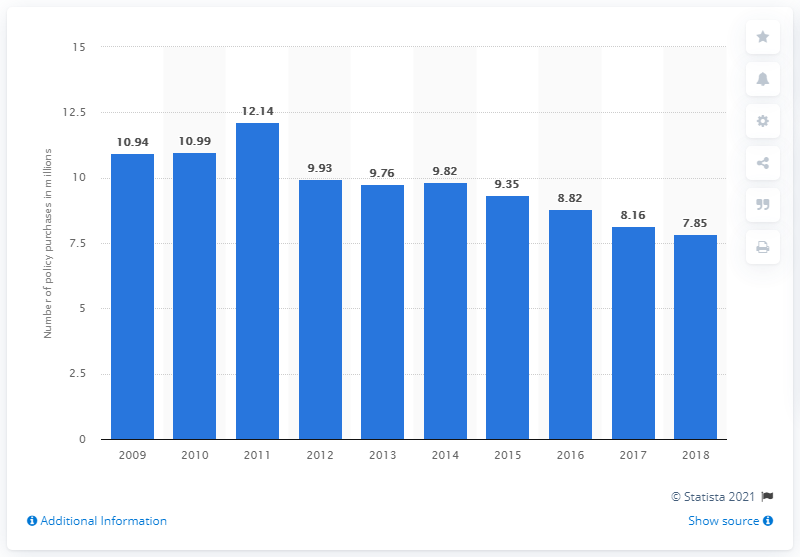Specify some key components in this picture. In the United States in 2018, 7.85 credit life insurance policies were purchased. 